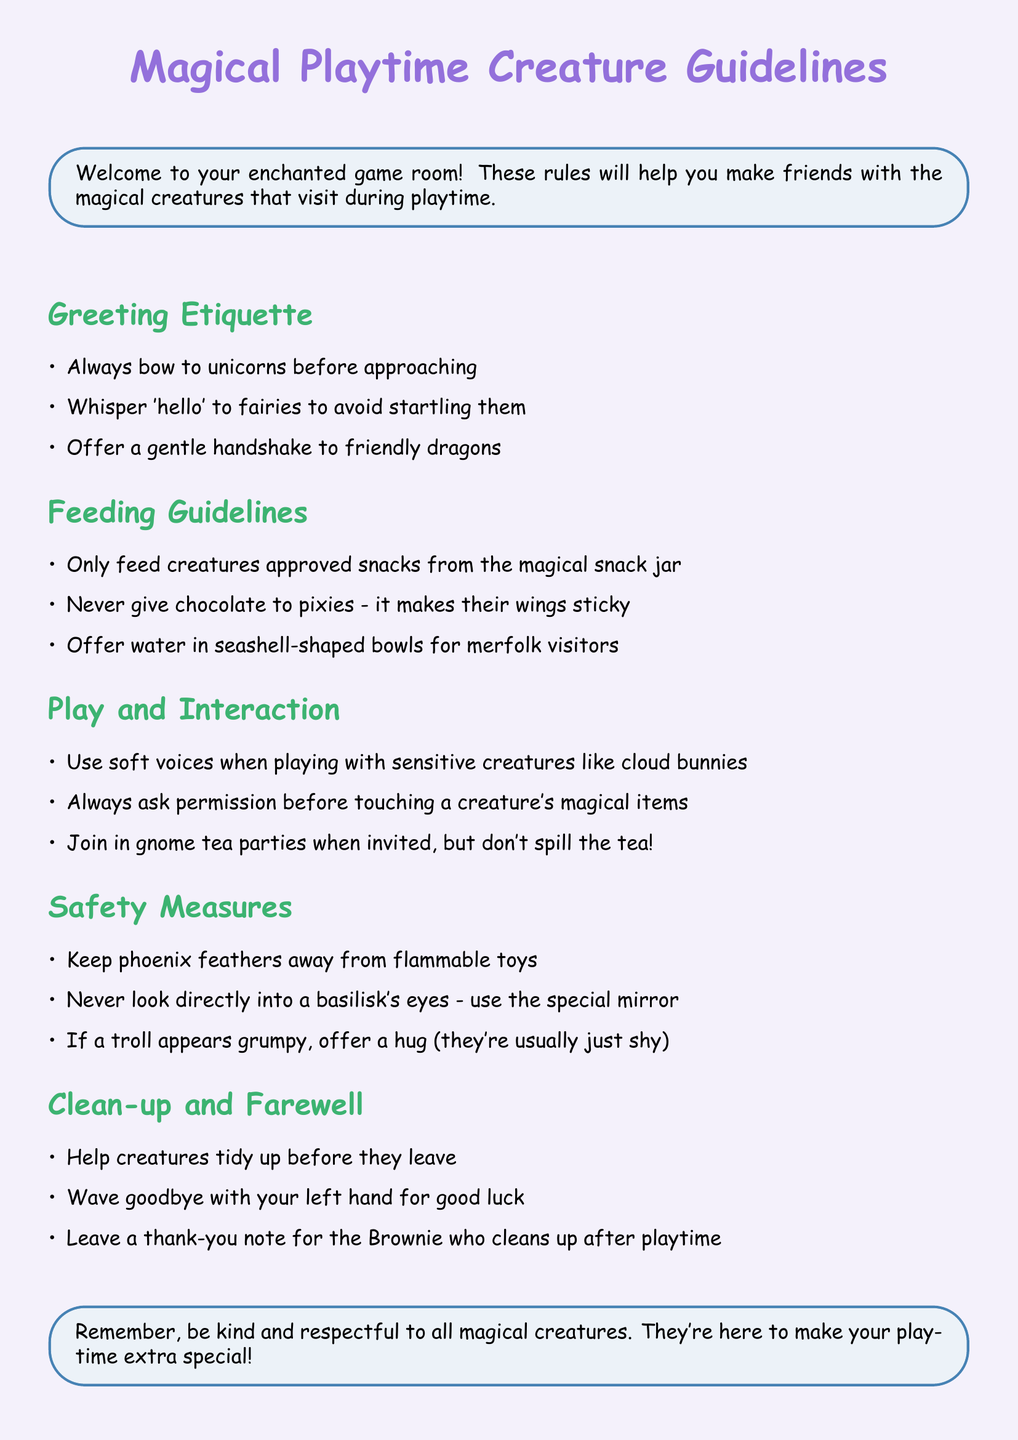What should you do before approaching a unicorn? The document states you should always bow to unicorns before approaching.
Answer: Bow What should you never give to pixies? The document specifies that you should never give chocolate to pixies because it makes their wings sticky.
Answer: Chocolate How should you interact with cloud bunnies? It states that you should use soft voices when playing with sensitive creatures like cloud bunnies.
Answer: Soft voices What is one safety measure when a troll appears grumpy? The guideline suggests offering a hug if a troll appears grumpy, as they're usually just shy.
Answer: Hug How do you bid farewell for good luck? The document mentions waving goodbye with your left hand for good luck.
Answer: Left hand What should you do if a merfolk visits? It mentions that you should offer water in seashell-shaped bowls for merfolk visitors.
Answer: Seashell-shaped bowls What is the first step in the Greeting Etiquette? The first step according to the document is to always bow to unicorns before approaching.
Answer: Bow to unicorns What should you do at gnome tea parties? The document instructs you to join in gnome tea parties when invited, but not to spill the tea.
Answer: Don't spill the tea What is left for the Brownie after playtime? It states that you should leave a thank-you note for the Brownie who cleans up after playtime.
Answer: Thank-you note 